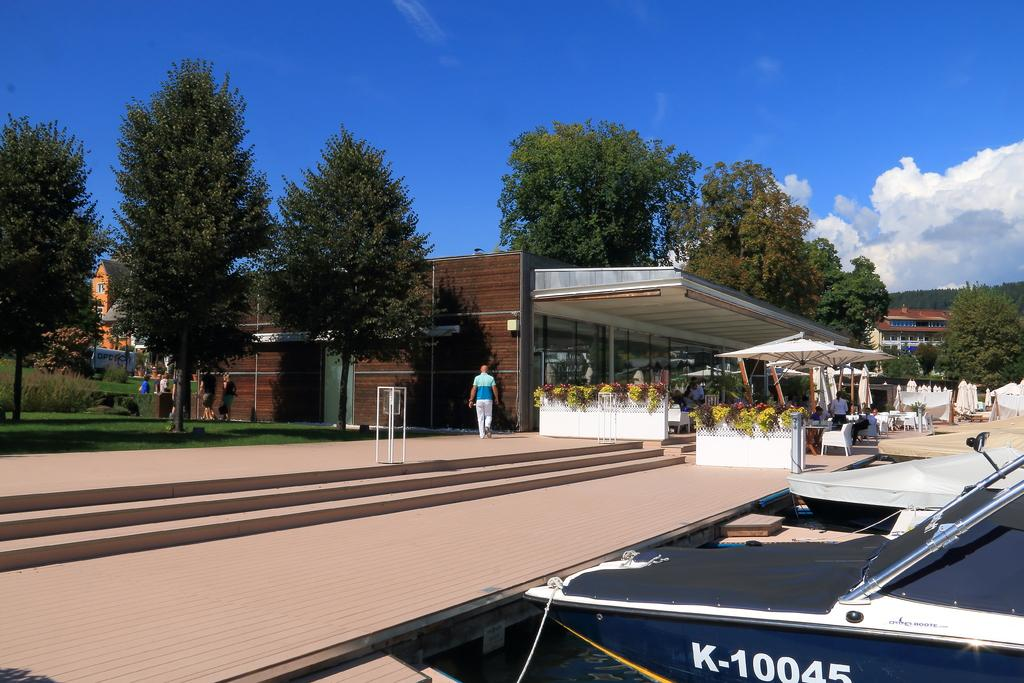What type of structure is visible in the image? There is a house in the image. What type of vegetation can be seen in the image? There are trees and plants in the image. What type of furniture is present in the image? There are chairs and a table in the image. Are there any people present in the image? Yes, there are people in the image. Can you describe any other objects visible in the image? There are other unspecified objects in the image. What language are the people speaking in the image? The provided facts do not mention any specific language being spoken in the image. How does the health of the trees in the image compare to the health of the plants? The provided facts do not include any information about the health of the trees or plants in the image. 